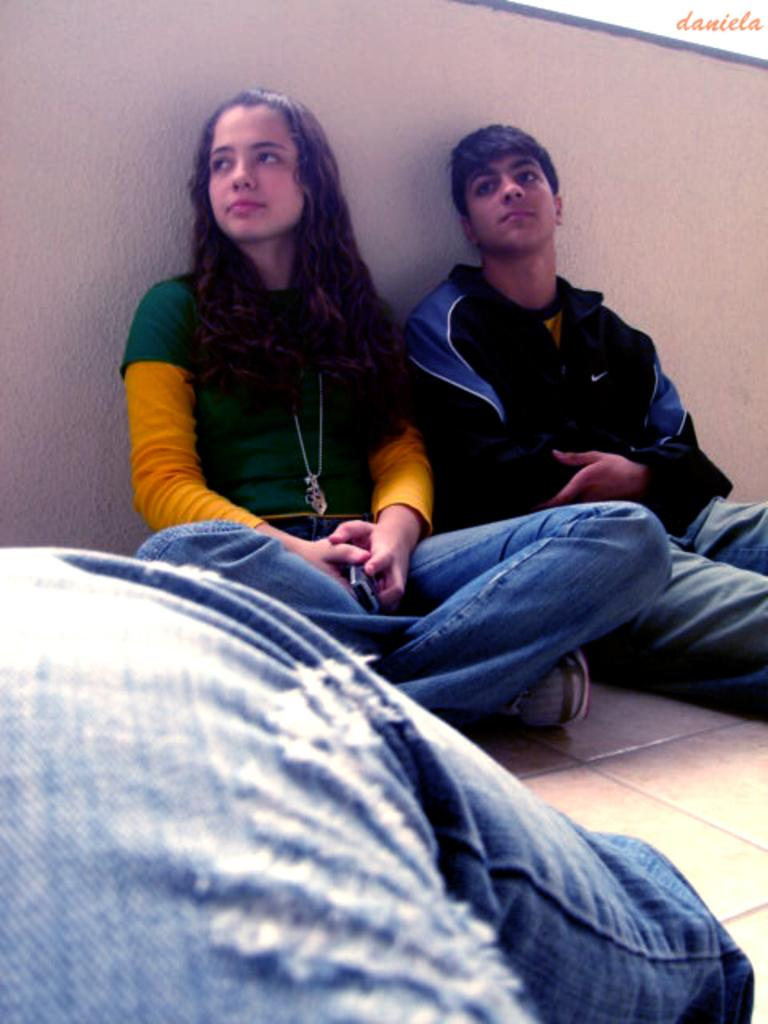What part of a person can be seen in the image? There is a person's leg visible in the image. How are the two people in the image positioned? Two people are sitting on the floor in the image. What can be seen in the background of the image? There is a wall in the background of the image. What type of quince is being used as a decoration in the image? There is no quince present in the image; it is not a decorative item or part of the scene. 